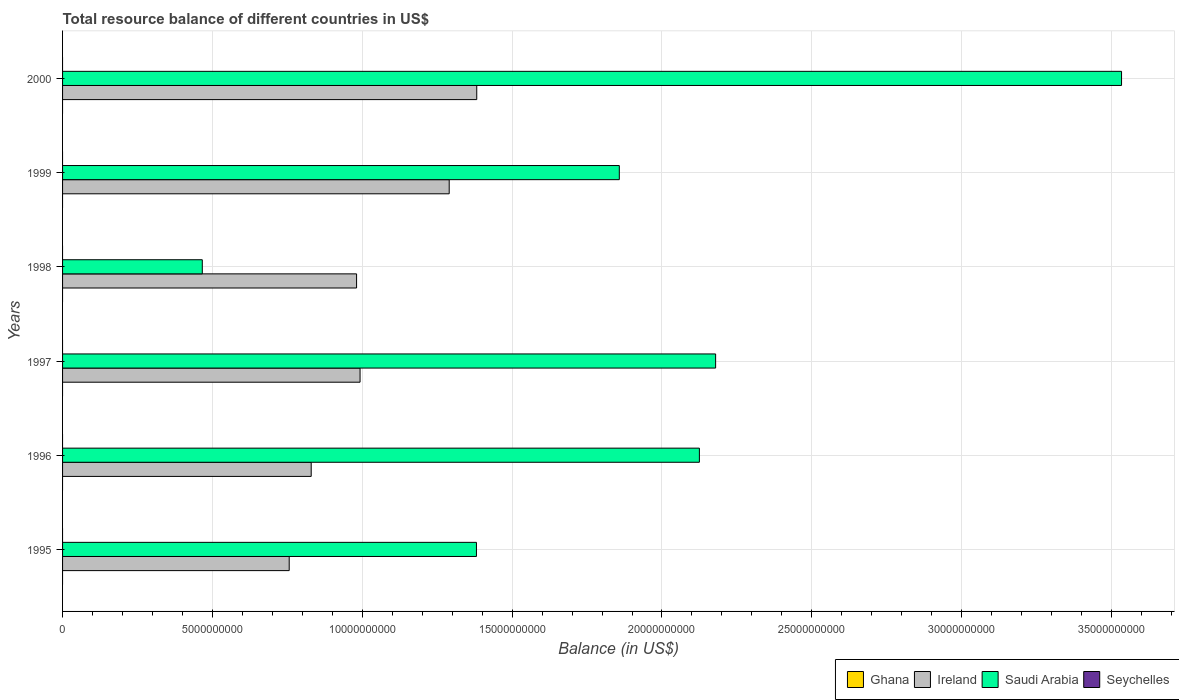How many groups of bars are there?
Make the answer very short. 6. Are the number of bars per tick equal to the number of legend labels?
Provide a short and direct response. No. Are the number of bars on each tick of the Y-axis equal?
Your answer should be compact. Yes. How many bars are there on the 6th tick from the bottom?
Ensure brevity in your answer.  2. What is the label of the 6th group of bars from the top?
Your response must be concise. 1995. In how many cases, is the number of bars for a given year not equal to the number of legend labels?
Make the answer very short. 6. What is the total resource balance in Saudi Arabia in 1996?
Offer a very short reply. 2.12e+1. Across all years, what is the maximum total resource balance in Ireland?
Offer a terse response. 1.38e+1. Across all years, what is the minimum total resource balance in Ireland?
Keep it short and to the point. 7.56e+09. What is the difference between the total resource balance in Saudi Arabia in 1998 and that in 1999?
Provide a short and direct response. -1.39e+1. What is the difference between the total resource balance in Saudi Arabia in 2000 and the total resource balance in Ghana in 1998?
Your answer should be very brief. 3.53e+1. What is the average total resource balance in Saudi Arabia per year?
Make the answer very short. 1.92e+1. In the year 1997, what is the difference between the total resource balance in Saudi Arabia and total resource balance in Ireland?
Give a very brief answer. 1.19e+1. In how many years, is the total resource balance in Seychelles greater than 7000000000 US$?
Offer a terse response. 0. What is the ratio of the total resource balance in Ireland in 1995 to that in 1998?
Make the answer very short. 0.77. Is the total resource balance in Ireland in 1995 less than that in 1996?
Your response must be concise. Yes. What is the difference between the highest and the second highest total resource balance in Saudi Arabia?
Keep it short and to the point. 1.35e+1. What is the difference between the highest and the lowest total resource balance in Ireland?
Give a very brief answer. 6.26e+09. Is the sum of the total resource balance in Saudi Arabia in 1995 and 1997 greater than the maximum total resource balance in Seychelles across all years?
Provide a succinct answer. Yes. Is it the case that in every year, the sum of the total resource balance in Seychelles and total resource balance in Saudi Arabia is greater than the sum of total resource balance in Ghana and total resource balance in Ireland?
Provide a succinct answer. No. How many bars are there?
Offer a terse response. 12. Are all the bars in the graph horizontal?
Make the answer very short. Yes. How many years are there in the graph?
Make the answer very short. 6. What is the difference between two consecutive major ticks on the X-axis?
Offer a very short reply. 5.00e+09. Are the values on the major ticks of X-axis written in scientific E-notation?
Make the answer very short. No. Does the graph contain any zero values?
Keep it short and to the point. Yes. Where does the legend appear in the graph?
Make the answer very short. Bottom right. How are the legend labels stacked?
Offer a very short reply. Horizontal. What is the title of the graph?
Offer a very short reply. Total resource balance of different countries in US$. Does "Swaziland" appear as one of the legend labels in the graph?
Provide a succinct answer. No. What is the label or title of the X-axis?
Your answer should be compact. Balance (in US$). What is the Balance (in US$) of Ireland in 1995?
Keep it short and to the point. 7.56e+09. What is the Balance (in US$) of Saudi Arabia in 1995?
Offer a terse response. 1.38e+1. What is the Balance (in US$) of Seychelles in 1995?
Your answer should be compact. 0. What is the Balance (in US$) in Ireland in 1996?
Provide a succinct answer. 8.30e+09. What is the Balance (in US$) of Saudi Arabia in 1996?
Ensure brevity in your answer.  2.12e+1. What is the Balance (in US$) of Ghana in 1997?
Provide a succinct answer. 0. What is the Balance (in US$) in Ireland in 1997?
Keep it short and to the point. 9.93e+09. What is the Balance (in US$) in Saudi Arabia in 1997?
Your response must be concise. 2.18e+1. What is the Balance (in US$) of Seychelles in 1997?
Ensure brevity in your answer.  0. What is the Balance (in US$) in Ireland in 1998?
Offer a terse response. 9.81e+09. What is the Balance (in US$) in Saudi Arabia in 1998?
Provide a short and direct response. 4.66e+09. What is the Balance (in US$) in Ghana in 1999?
Your answer should be compact. 0. What is the Balance (in US$) of Ireland in 1999?
Offer a terse response. 1.29e+1. What is the Balance (in US$) of Saudi Arabia in 1999?
Keep it short and to the point. 1.86e+1. What is the Balance (in US$) of Seychelles in 1999?
Make the answer very short. 0. What is the Balance (in US$) in Ghana in 2000?
Your answer should be very brief. 0. What is the Balance (in US$) of Ireland in 2000?
Your answer should be compact. 1.38e+1. What is the Balance (in US$) in Saudi Arabia in 2000?
Make the answer very short. 3.53e+1. Across all years, what is the maximum Balance (in US$) in Ireland?
Offer a terse response. 1.38e+1. Across all years, what is the maximum Balance (in US$) in Saudi Arabia?
Make the answer very short. 3.53e+1. Across all years, what is the minimum Balance (in US$) in Ireland?
Give a very brief answer. 7.56e+09. Across all years, what is the minimum Balance (in US$) in Saudi Arabia?
Offer a very short reply. 4.66e+09. What is the total Balance (in US$) in Ireland in the graph?
Provide a short and direct response. 6.23e+1. What is the total Balance (in US$) in Saudi Arabia in the graph?
Keep it short and to the point. 1.15e+11. What is the difference between the Balance (in US$) in Ireland in 1995 and that in 1996?
Your answer should be compact. -7.34e+08. What is the difference between the Balance (in US$) of Saudi Arabia in 1995 and that in 1996?
Ensure brevity in your answer.  -7.44e+09. What is the difference between the Balance (in US$) of Ireland in 1995 and that in 1997?
Provide a succinct answer. -2.36e+09. What is the difference between the Balance (in US$) in Saudi Arabia in 1995 and that in 1997?
Keep it short and to the point. -7.98e+09. What is the difference between the Balance (in US$) in Ireland in 1995 and that in 1998?
Provide a short and direct response. -2.25e+09. What is the difference between the Balance (in US$) of Saudi Arabia in 1995 and that in 1998?
Ensure brevity in your answer.  9.15e+09. What is the difference between the Balance (in US$) in Ireland in 1995 and that in 1999?
Offer a terse response. -5.34e+09. What is the difference between the Balance (in US$) in Saudi Arabia in 1995 and that in 1999?
Keep it short and to the point. -4.77e+09. What is the difference between the Balance (in US$) in Ireland in 1995 and that in 2000?
Your answer should be very brief. -6.26e+09. What is the difference between the Balance (in US$) of Saudi Arabia in 1995 and that in 2000?
Offer a terse response. -2.15e+1. What is the difference between the Balance (in US$) of Ireland in 1996 and that in 1997?
Provide a short and direct response. -1.63e+09. What is the difference between the Balance (in US$) in Saudi Arabia in 1996 and that in 1997?
Provide a succinct answer. -5.42e+08. What is the difference between the Balance (in US$) of Ireland in 1996 and that in 1998?
Your answer should be compact. -1.51e+09. What is the difference between the Balance (in US$) in Saudi Arabia in 1996 and that in 1998?
Your answer should be compact. 1.66e+1. What is the difference between the Balance (in US$) in Ireland in 1996 and that in 1999?
Your response must be concise. -4.60e+09. What is the difference between the Balance (in US$) in Saudi Arabia in 1996 and that in 1999?
Provide a short and direct response. 2.67e+09. What is the difference between the Balance (in US$) of Ireland in 1996 and that in 2000?
Ensure brevity in your answer.  -5.52e+09. What is the difference between the Balance (in US$) in Saudi Arabia in 1996 and that in 2000?
Make the answer very short. -1.41e+1. What is the difference between the Balance (in US$) in Ireland in 1997 and that in 1998?
Offer a terse response. 1.16e+08. What is the difference between the Balance (in US$) of Saudi Arabia in 1997 and that in 1998?
Your response must be concise. 1.71e+1. What is the difference between the Balance (in US$) of Ireland in 1997 and that in 1999?
Offer a terse response. -2.97e+09. What is the difference between the Balance (in US$) of Saudi Arabia in 1997 and that in 1999?
Provide a succinct answer. 3.21e+09. What is the difference between the Balance (in US$) in Ireland in 1997 and that in 2000?
Your response must be concise. -3.89e+09. What is the difference between the Balance (in US$) in Saudi Arabia in 1997 and that in 2000?
Your answer should be very brief. -1.35e+1. What is the difference between the Balance (in US$) of Ireland in 1998 and that in 1999?
Offer a very short reply. -3.09e+09. What is the difference between the Balance (in US$) in Saudi Arabia in 1998 and that in 1999?
Offer a terse response. -1.39e+1. What is the difference between the Balance (in US$) in Ireland in 1998 and that in 2000?
Ensure brevity in your answer.  -4.01e+09. What is the difference between the Balance (in US$) of Saudi Arabia in 1998 and that in 2000?
Ensure brevity in your answer.  -3.07e+1. What is the difference between the Balance (in US$) in Ireland in 1999 and that in 2000?
Keep it short and to the point. -9.19e+08. What is the difference between the Balance (in US$) in Saudi Arabia in 1999 and that in 2000?
Provide a short and direct response. -1.68e+1. What is the difference between the Balance (in US$) in Ireland in 1995 and the Balance (in US$) in Saudi Arabia in 1996?
Ensure brevity in your answer.  -1.37e+1. What is the difference between the Balance (in US$) in Ireland in 1995 and the Balance (in US$) in Saudi Arabia in 1997?
Provide a short and direct response. -1.42e+1. What is the difference between the Balance (in US$) in Ireland in 1995 and the Balance (in US$) in Saudi Arabia in 1998?
Offer a terse response. 2.90e+09. What is the difference between the Balance (in US$) of Ireland in 1995 and the Balance (in US$) of Saudi Arabia in 1999?
Offer a terse response. -1.10e+1. What is the difference between the Balance (in US$) of Ireland in 1995 and the Balance (in US$) of Saudi Arabia in 2000?
Make the answer very short. -2.78e+1. What is the difference between the Balance (in US$) in Ireland in 1996 and the Balance (in US$) in Saudi Arabia in 1997?
Give a very brief answer. -1.35e+1. What is the difference between the Balance (in US$) of Ireland in 1996 and the Balance (in US$) of Saudi Arabia in 1998?
Make the answer very short. 3.63e+09. What is the difference between the Balance (in US$) in Ireland in 1996 and the Balance (in US$) in Saudi Arabia in 1999?
Ensure brevity in your answer.  -1.03e+1. What is the difference between the Balance (in US$) of Ireland in 1996 and the Balance (in US$) of Saudi Arabia in 2000?
Offer a terse response. -2.70e+1. What is the difference between the Balance (in US$) of Ireland in 1997 and the Balance (in US$) of Saudi Arabia in 1998?
Provide a short and direct response. 5.26e+09. What is the difference between the Balance (in US$) in Ireland in 1997 and the Balance (in US$) in Saudi Arabia in 1999?
Offer a very short reply. -8.65e+09. What is the difference between the Balance (in US$) in Ireland in 1997 and the Balance (in US$) in Saudi Arabia in 2000?
Your answer should be very brief. -2.54e+1. What is the difference between the Balance (in US$) in Ireland in 1998 and the Balance (in US$) in Saudi Arabia in 1999?
Give a very brief answer. -8.77e+09. What is the difference between the Balance (in US$) of Ireland in 1998 and the Balance (in US$) of Saudi Arabia in 2000?
Make the answer very short. -2.55e+1. What is the difference between the Balance (in US$) of Ireland in 1999 and the Balance (in US$) of Saudi Arabia in 2000?
Keep it short and to the point. -2.24e+1. What is the average Balance (in US$) in Ireland per year?
Your answer should be compact. 1.04e+1. What is the average Balance (in US$) in Saudi Arabia per year?
Your answer should be compact. 1.92e+1. In the year 1995, what is the difference between the Balance (in US$) of Ireland and Balance (in US$) of Saudi Arabia?
Offer a terse response. -6.25e+09. In the year 1996, what is the difference between the Balance (in US$) of Ireland and Balance (in US$) of Saudi Arabia?
Ensure brevity in your answer.  -1.30e+1. In the year 1997, what is the difference between the Balance (in US$) of Ireland and Balance (in US$) of Saudi Arabia?
Ensure brevity in your answer.  -1.19e+1. In the year 1998, what is the difference between the Balance (in US$) in Ireland and Balance (in US$) in Saudi Arabia?
Offer a terse response. 5.15e+09. In the year 1999, what is the difference between the Balance (in US$) of Ireland and Balance (in US$) of Saudi Arabia?
Provide a short and direct response. -5.68e+09. In the year 2000, what is the difference between the Balance (in US$) of Ireland and Balance (in US$) of Saudi Arabia?
Give a very brief answer. -2.15e+1. What is the ratio of the Balance (in US$) of Ireland in 1995 to that in 1996?
Ensure brevity in your answer.  0.91. What is the ratio of the Balance (in US$) of Saudi Arabia in 1995 to that in 1996?
Keep it short and to the point. 0.65. What is the ratio of the Balance (in US$) of Ireland in 1995 to that in 1997?
Provide a succinct answer. 0.76. What is the ratio of the Balance (in US$) in Saudi Arabia in 1995 to that in 1997?
Your answer should be very brief. 0.63. What is the ratio of the Balance (in US$) in Ireland in 1995 to that in 1998?
Give a very brief answer. 0.77. What is the ratio of the Balance (in US$) of Saudi Arabia in 1995 to that in 1998?
Keep it short and to the point. 2.96. What is the ratio of the Balance (in US$) in Ireland in 1995 to that in 1999?
Your response must be concise. 0.59. What is the ratio of the Balance (in US$) of Saudi Arabia in 1995 to that in 1999?
Your answer should be compact. 0.74. What is the ratio of the Balance (in US$) in Ireland in 1995 to that in 2000?
Offer a very short reply. 0.55. What is the ratio of the Balance (in US$) in Saudi Arabia in 1995 to that in 2000?
Your answer should be compact. 0.39. What is the ratio of the Balance (in US$) of Ireland in 1996 to that in 1997?
Offer a terse response. 0.84. What is the ratio of the Balance (in US$) in Saudi Arabia in 1996 to that in 1997?
Your answer should be very brief. 0.98. What is the ratio of the Balance (in US$) of Ireland in 1996 to that in 1998?
Provide a succinct answer. 0.85. What is the ratio of the Balance (in US$) in Saudi Arabia in 1996 to that in 1998?
Your answer should be very brief. 4.56. What is the ratio of the Balance (in US$) in Ireland in 1996 to that in 1999?
Keep it short and to the point. 0.64. What is the ratio of the Balance (in US$) of Saudi Arabia in 1996 to that in 1999?
Make the answer very short. 1.14. What is the ratio of the Balance (in US$) in Ireland in 1996 to that in 2000?
Make the answer very short. 0.6. What is the ratio of the Balance (in US$) in Saudi Arabia in 1996 to that in 2000?
Offer a very short reply. 0.6. What is the ratio of the Balance (in US$) in Ireland in 1997 to that in 1998?
Give a very brief answer. 1.01. What is the ratio of the Balance (in US$) in Saudi Arabia in 1997 to that in 1998?
Provide a succinct answer. 4.67. What is the ratio of the Balance (in US$) in Ireland in 1997 to that in 1999?
Offer a very short reply. 0.77. What is the ratio of the Balance (in US$) of Saudi Arabia in 1997 to that in 1999?
Your response must be concise. 1.17. What is the ratio of the Balance (in US$) in Ireland in 1997 to that in 2000?
Provide a succinct answer. 0.72. What is the ratio of the Balance (in US$) in Saudi Arabia in 1997 to that in 2000?
Keep it short and to the point. 0.62. What is the ratio of the Balance (in US$) of Ireland in 1998 to that in 1999?
Give a very brief answer. 0.76. What is the ratio of the Balance (in US$) of Saudi Arabia in 1998 to that in 1999?
Give a very brief answer. 0.25. What is the ratio of the Balance (in US$) of Ireland in 1998 to that in 2000?
Provide a succinct answer. 0.71. What is the ratio of the Balance (in US$) of Saudi Arabia in 1998 to that in 2000?
Provide a short and direct response. 0.13. What is the ratio of the Balance (in US$) in Ireland in 1999 to that in 2000?
Give a very brief answer. 0.93. What is the ratio of the Balance (in US$) of Saudi Arabia in 1999 to that in 2000?
Provide a short and direct response. 0.53. What is the difference between the highest and the second highest Balance (in US$) in Ireland?
Offer a very short reply. 9.19e+08. What is the difference between the highest and the second highest Balance (in US$) of Saudi Arabia?
Your answer should be very brief. 1.35e+1. What is the difference between the highest and the lowest Balance (in US$) in Ireland?
Keep it short and to the point. 6.26e+09. What is the difference between the highest and the lowest Balance (in US$) of Saudi Arabia?
Offer a terse response. 3.07e+1. 